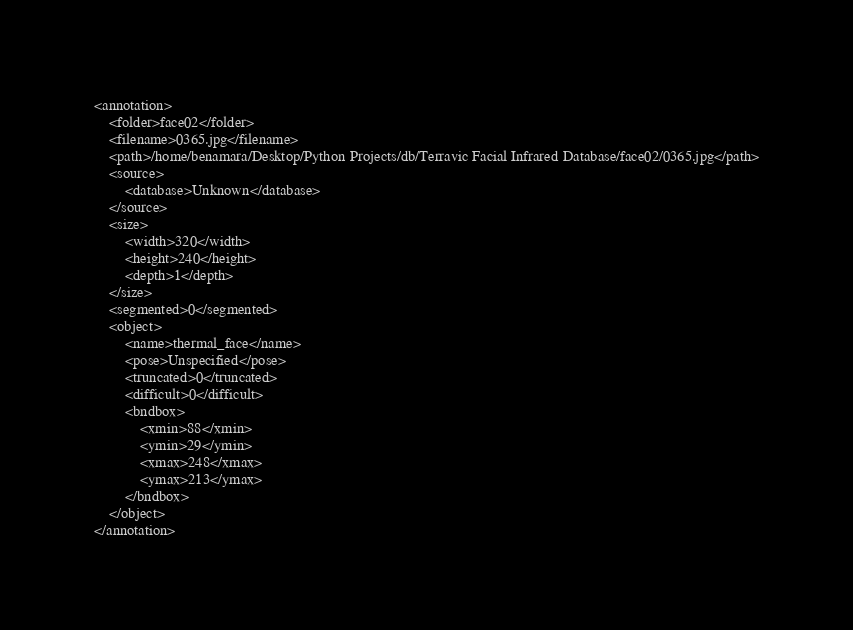<code> <loc_0><loc_0><loc_500><loc_500><_XML_><annotation>
	<folder>face02</folder>
	<filename>0365.jpg</filename>
	<path>/home/benamara/Desktop/Python Projects/db/Terravic Facial Infrared Database/face02/0365.jpg</path>
	<source>
		<database>Unknown</database>
	</source>
	<size>
		<width>320</width>
		<height>240</height>
		<depth>1</depth>
	</size>
	<segmented>0</segmented>
	<object>
		<name>thermal_face</name>
		<pose>Unspecified</pose>
		<truncated>0</truncated>
		<difficult>0</difficult>
		<bndbox>
			<xmin>88</xmin>
			<ymin>29</ymin>
			<xmax>248</xmax>
			<ymax>213</ymax>
		</bndbox>
	</object>
</annotation>
</code> 